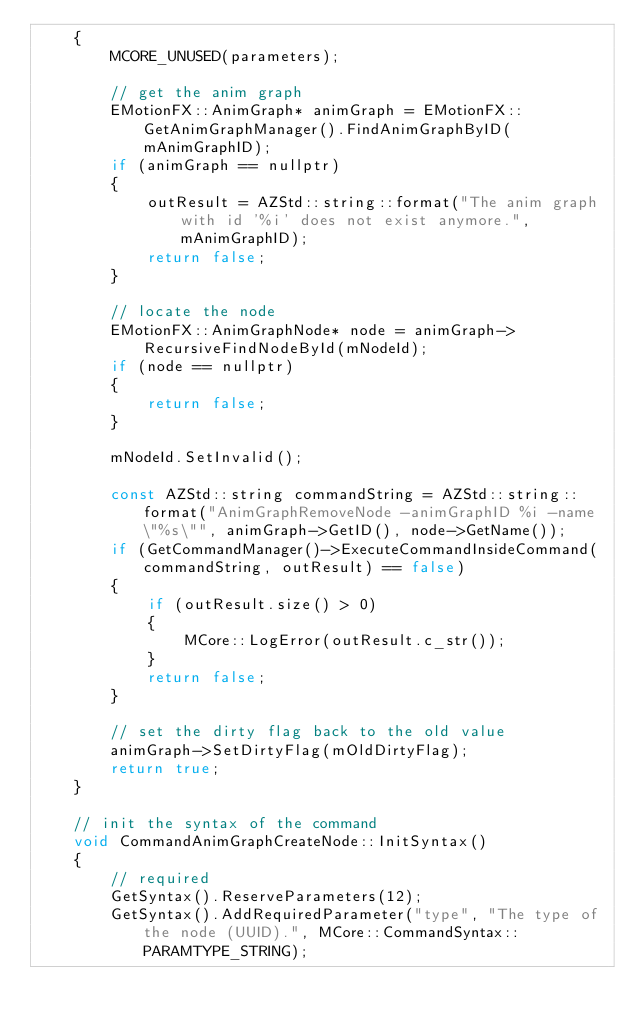<code> <loc_0><loc_0><loc_500><loc_500><_C++_>    {
        MCORE_UNUSED(parameters);

        // get the anim graph
        EMotionFX::AnimGraph* animGraph = EMotionFX::GetAnimGraphManager().FindAnimGraphByID(mAnimGraphID);
        if (animGraph == nullptr)
        {
            outResult = AZStd::string::format("The anim graph with id '%i' does not exist anymore.", mAnimGraphID);
            return false;
        }

        // locate the node
        EMotionFX::AnimGraphNode* node = animGraph->RecursiveFindNodeById(mNodeId);
        if (node == nullptr)
        {
            return false;
        }

        mNodeId.SetInvalid();

        const AZStd::string commandString = AZStd::string::format("AnimGraphRemoveNode -animGraphID %i -name \"%s\"", animGraph->GetID(), node->GetName());
        if (GetCommandManager()->ExecuteCommandInsideCommand(commandString, outResult) == false)
        {
            if (outResult.size() > 0)
            {
                MCore::LogError(outResult.c_str());
            }
            return false;
        }

        // set the dirty flag back to the old value
        animGraph->SetDirtyFlag(mOldDirtyFlag);
        return true;
    }

    // init the syntax of the command
    void CommandAnimGraphCreateNode::InitSyntax()
    {
        // required
        GetSyntax().ReserveParameters(12);
        GetSyntax().AddRequiredParameter("type", "The type of the node (UUID).", MCore::CommandSyntax::PARAMTYPE_STRING);</code> 